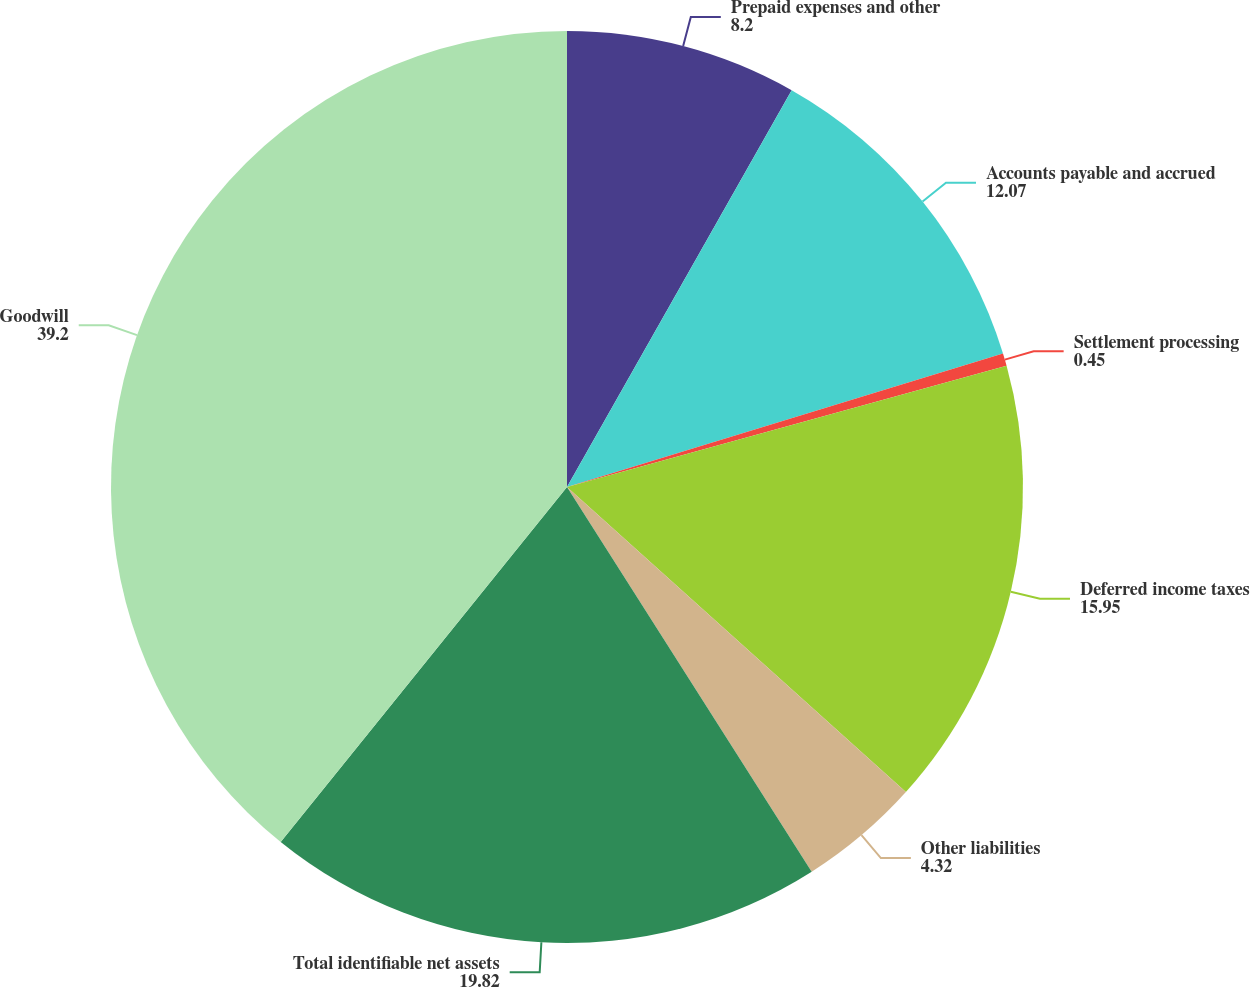<chart> <loc_0><loc_0><loc_500><loc_500><pie_chart><fcel>Prepaid expenses and other<fcel>Accounts payable and accrued<fcel>Settlement processing<fcel>Deferred income taxes<fcel>Other liabilities<fcel>Total identifiable net assets<fcel>Goodwill<nl><fcel>8.2%<fcel>12.07%<fcel>0.45%<fcel>15.95%<fcel>4.32%<fcel>19.82%<fcel>39.2%<nl></chart> 